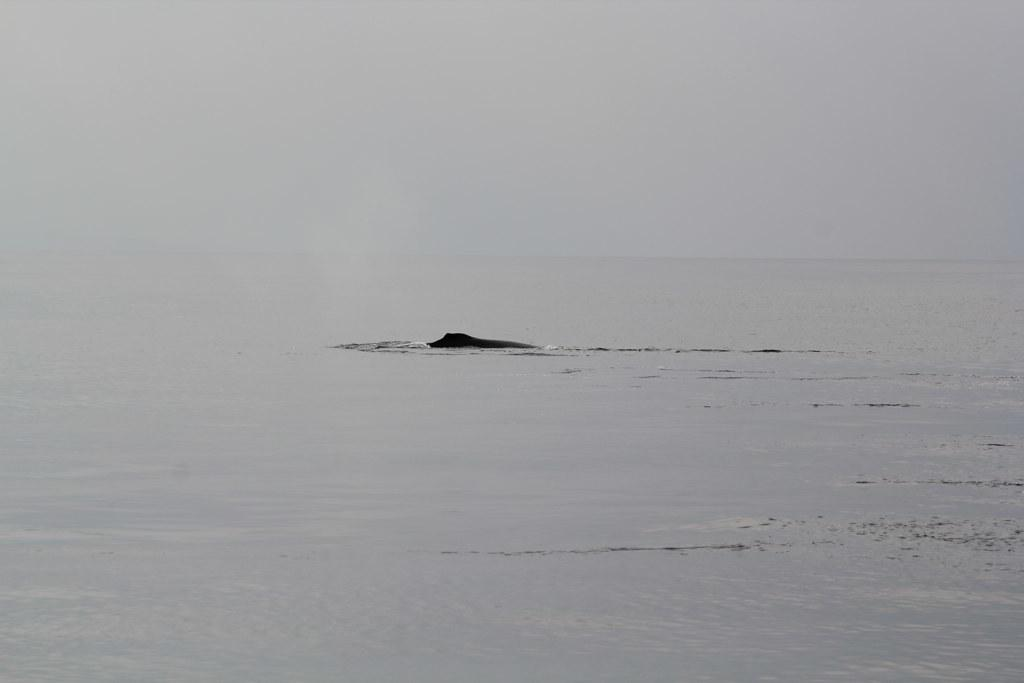What can be seen in the image that is not solid? There is water visible in the image. What part of the natural environment is visible in the image? The sky is visible in the image. Can you tell me how many donkeys are visible in the image? There are no donkeys present in the image. What type of trail can be seen in the image? There is no trail visible in the image. 